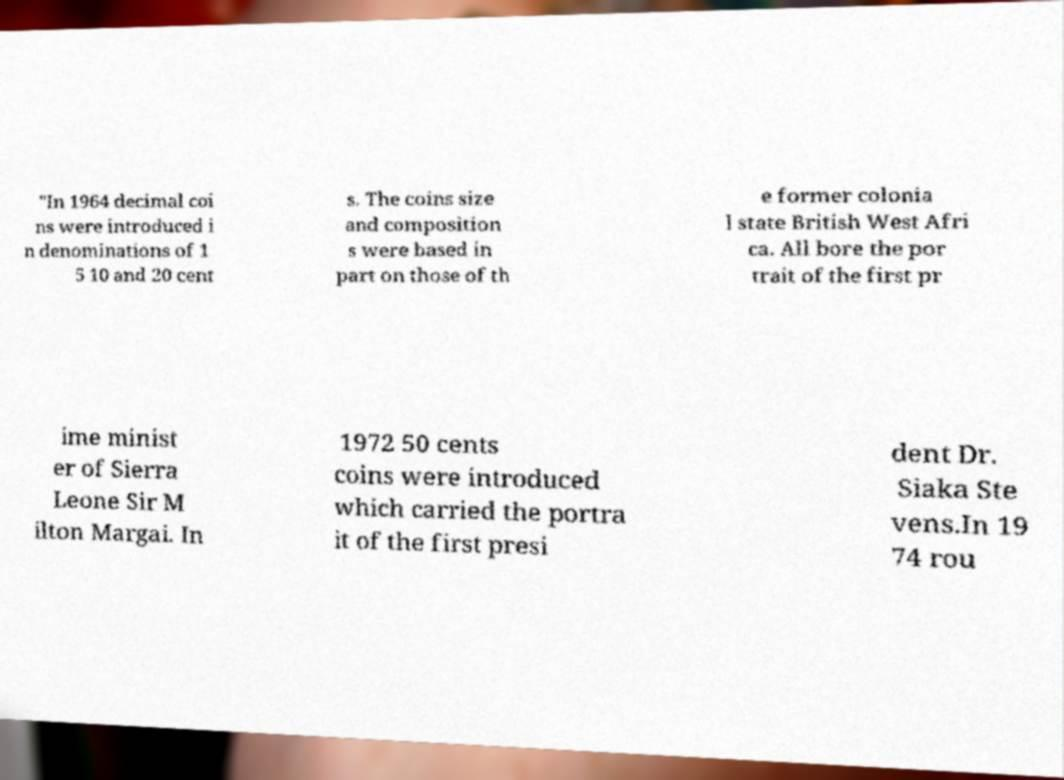Please read and relay the text visible in this image. What does it say? "In 1964 decimal coi ns were introduced i n denominations of 1 5 10 and 20 cent s. The coins size and composition s were based in part on those of th e former colonia l state British West Afri ca. All bore the por trait of the first pr ime minist er of Sierra Leone Sir M ilton Margai. In 1972 50 cents coins were introduced which carried the portra it of the first presi dent Dr. Siaka Ste vens.In 19 74 rou 